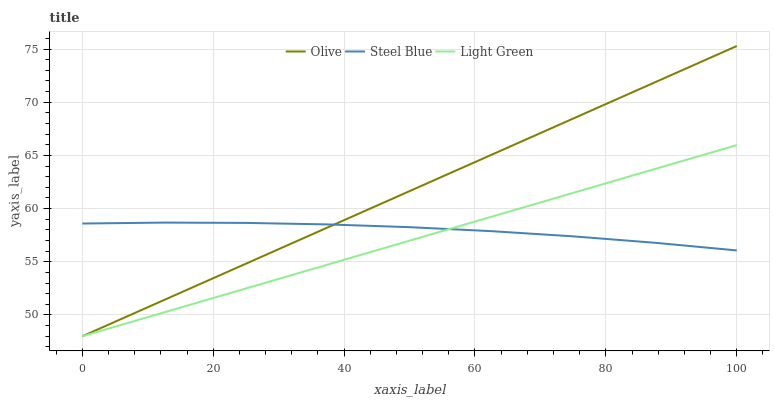Does Light Green have the minimum area under the curve?
Answer yes or no. Yes. Does Olive have the maximum area under the curve?
Answer yes or no. Yes. Does Steel Blue have the minimum area under the curve?
Answer yes or no. No. Does Steel Blue have the maximum area under the curve?
Answer yes or no. No. Is Light Green the smoothest?
Answer yes or no. Yes. Is Steel Blue the roughest?
Answer yes or no. Yes. Is Steel Blue the smoothest?
Answer yes or no. No. Is Light Green the roughest?
Answer yes or no. No. Does Olive have the lowest value?
Answer yes or no. Yes. Does Steel Blue have the lowest value?
Answer yes or no. No. Does Olive have the highest value?
Answer yes or no. Yes. Does Light Green have the highest value?
Answer yes or no. No. Does Steel Blue intersect Light Green?
Answer yes or no. Yes. Is Steel Blue less than Light Green?
Answer yes or no. No. Is Steel Blue greater than Light Green?
Answer yes or no. No. 